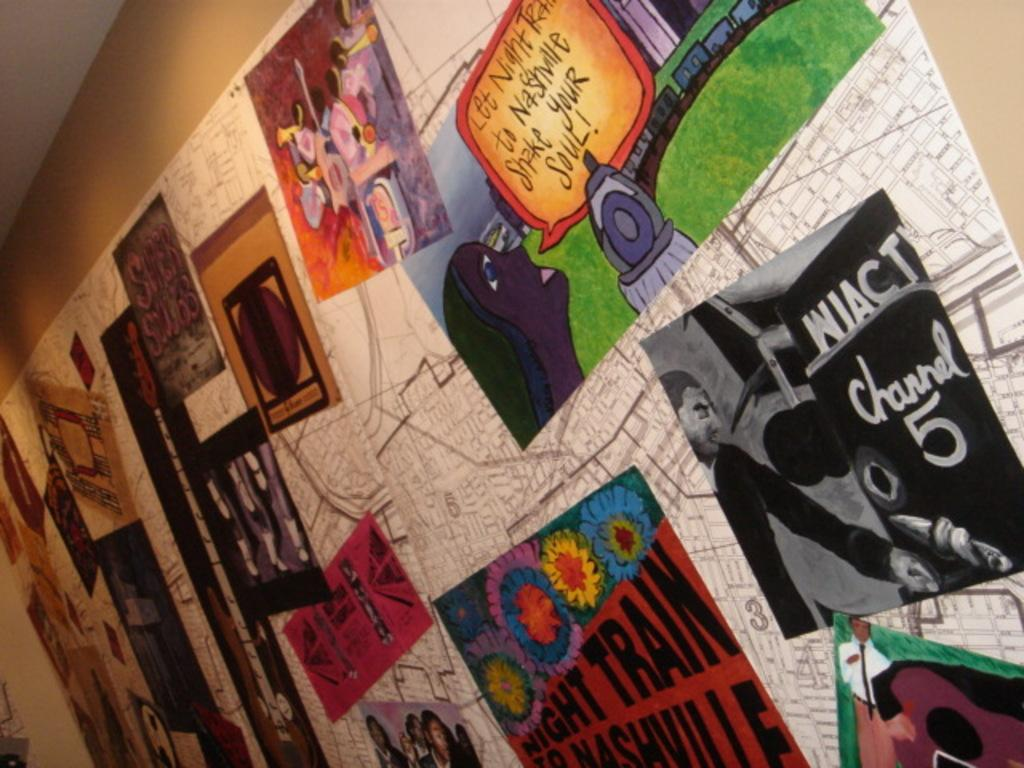<image>
Render a clear and concise summary of the photo. A poster on the wall that says Night Train to Nashville. 